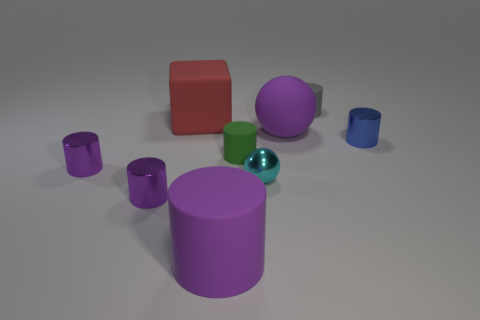Subtract all green blocks. How many purple cylinders are left? 3 Subtract all gray cylinders. How many cylinders are left? 5 Subtract all blue cylinders. How many cylinders are left? 5 Subtract all yellow cylinders. Subtract all cyan spheres. How many cylinders are left? 6 Subtract all balls. How many objects are left? 7 Subtract 0 blue spheres. How many objects are left? 9 Subtract all red rubber things. Subtract all tiny purple metal things. How many objects are left? 6 Add 9 tiny blue shiny objects. How many tiny blue shiny objects are left? 10 Add 2 green rubber cylinders. How many green rubber cylinders exist? 3 